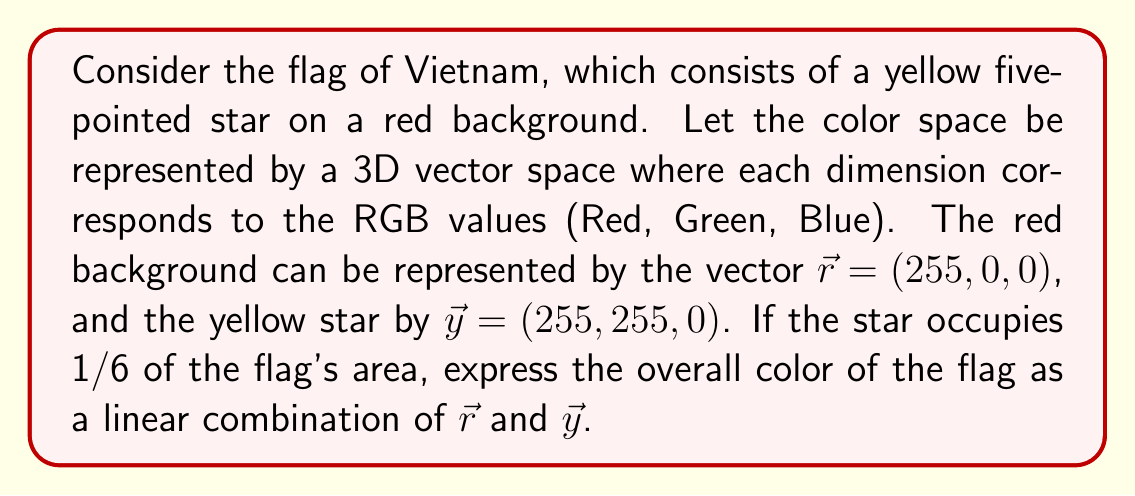Can you answer this question? To solve this problem, we need to follow these steps:

1) First, we need to determine the coefficients for the linear combination based on the area occupied by each color:
   - Red background: 5/6 of the flag's area
   - Yellow star: 1/6 of the flag's area

2) The linear combination will be in the form:
   $$\vec{f} = a\vec{r} + b\vec{y}$$
   where $\vec{f}$ is the overall color vector, and $a$ and $b$ are the coefficients.

3) Based on the area proportions, we can set:
   $a = 5/6$ and $b = 1/6$

4) Now, let's substitute the values:
   $$\vec{f} = \frac{5}{6}(255, 0, 0) + \frac{1}{6}(255, 255, 0)$$

5) Let's calculate this:
   $$\vec{f} = (\frac{5}{6} \cdot 255, 0, 0) + (\frac{1}{6} \cdot 255, \frac{1}{6} \cdot 255, 0)$$
   $$\vec{f} = (212.5, 0, 0) + (42.5, 42.5, 0)$$

6) Adding these vectors:
   $$\vec{f} = (255, 42.5, 0)$$

7) Therefore, the overall color of the flag can be represented by the vector (255, 42.5, 0) in the RGB color space.
Answer: $\vec{f} = (255, 42.5, 0)$ 